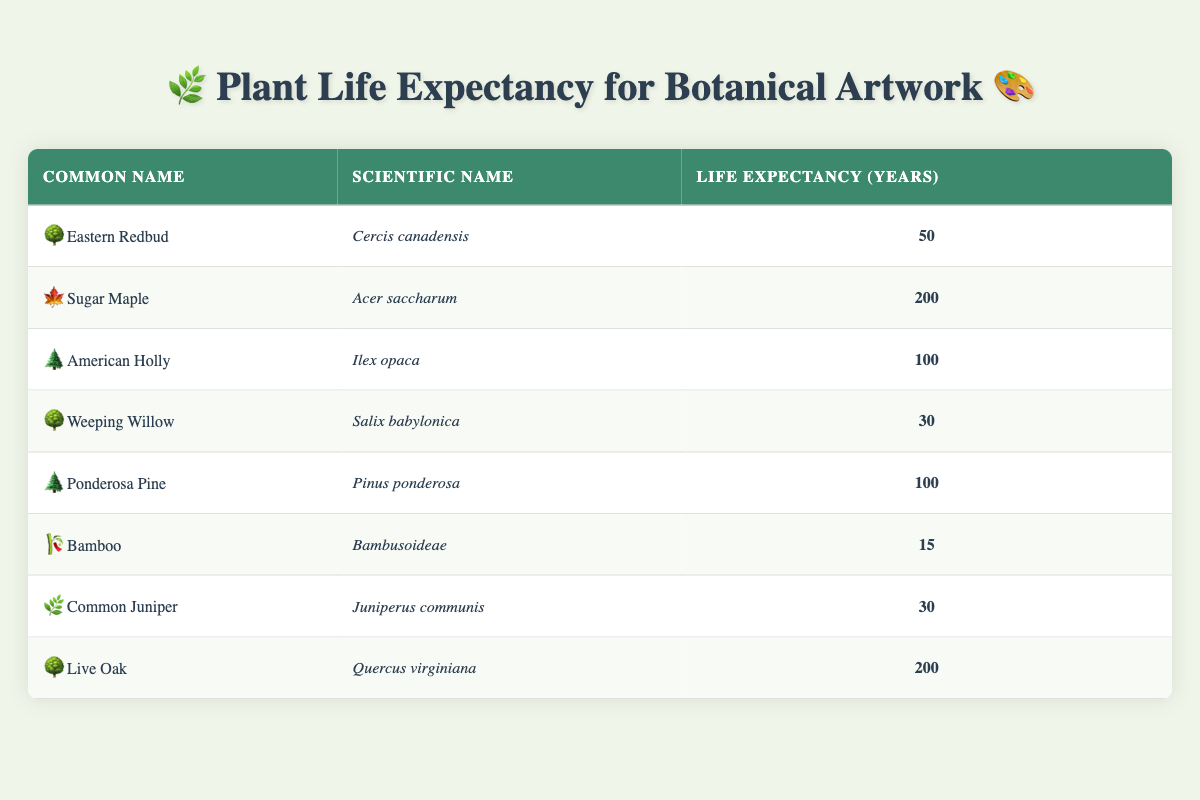What is the life expectancy of the Sugar Maple? The life expectancy for Sugar Maple, listed in the table, is directly provided as 200 years.
Answer: 200 years Which plant species has the shortest life expectancy? The table shows that Bamboo has the shortest life expectancy at 15 years, which is less than any other species listed.
Answer: Bamboo: 15 years How many species have a life expectancy of 100 years or more? Referring to the table, we find three species: Sugar Maple (200 years), American Holly (100 years), and Ponderosa Pine (100 years).
Answer: 3 species What is the average life expectancy of all the plant species listed? To calculate the average, sum the life expectancies: (50 + 200 + 100 + 30 + 100 + 15 + 30 + 200) = 725, then divide by the number of species (8), resulting in 725/8 = 90.625.
Answer: 90.625 years Is the life expectancy of the Eastern Redbud greater than that of the Common Juniper? The table shows Eastern Redbud with a life expectancy of 50 years and Common Juniper with 30 years. Since 50 is greater than 30, the statement is true.
Answer: Yes What is the difference in life expectancy between Live Oak and Weeping Willow? Live Oak has a life expectancy of 200 years and Weeping Willow has 30 years. The difference is 200 - 30 = 170 years.
Answer: 170 years Which species have a life expectancy of less than 50 years? Looking at the table, two species meet this criterion: Weeping Willow (30 years) and Bamboo (15 years).
Answer: Weeping Willow and Bamboo How many species listed have a life expectancy of exactly 30 years? By reviewing the table, we find two species with a life expectancy of 30 years: Weeping Willow and Common Juniper.
Answer: 2 species 